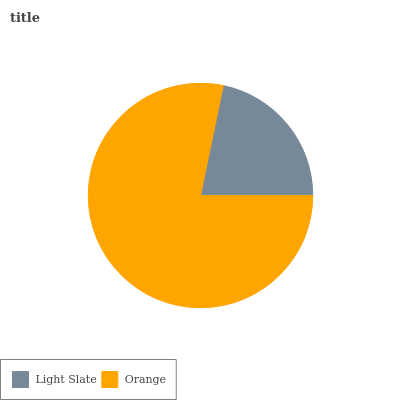Is Light Slate the minimum?
Answer yes or no. Yes. Is Orange the maximum?
Answer yes or no. Yes. Is Orange the minimum?
Answer yes or no. No. Is Orange greater than Light Slate?
Answer yes or no. Yes. Is Light Slate less than Orange?
Answer yes or no. Yes. Is Light Slate greater than Orange?
Answer yes or no. No. Is Orange less than Light Slate?
Answer yes or no. No. Is Orange the high median?
Answer yes or no. Yes. Is Light Slate the low median?
Answer yes or no. Yes. Is Light Slate the high median?
Answer yes or no. No. Is Orange the low median?
Answer yes or no. No. 